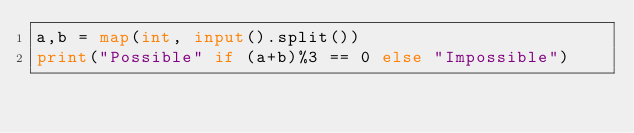<code> <loc_0><loc_0><loc_500><loc_500><_Python_>a,b = map(int, input().split())
print("Possible" if (a+b)%3 == 0 else "Impossible")</code> 